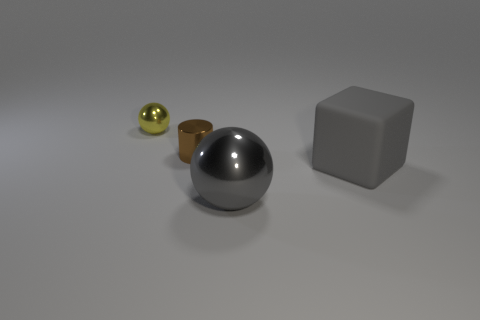Add 4 blocks. How many objects exist? 8 Subtract all gray spheres. How many spheres are left? 1 Add 2 small cyan matte balls. How many small cyan matte balls exist? 2 Subtract 1 gray cubes. How many objects are left? 3 Subtract 1 balls. How many balls are left? 1 Subtract all blue blocks. Subtract all brown cylinders. How many blocks are left? 1 Subtract all gray cylinders. How many cyan cubes are left? 0 Subtract all yellow metallic cylinders. Subtract all big metallic balls. How many objects are left? 3 Add 3 tiny cylinders. How many tiny cylinders are left? 4 